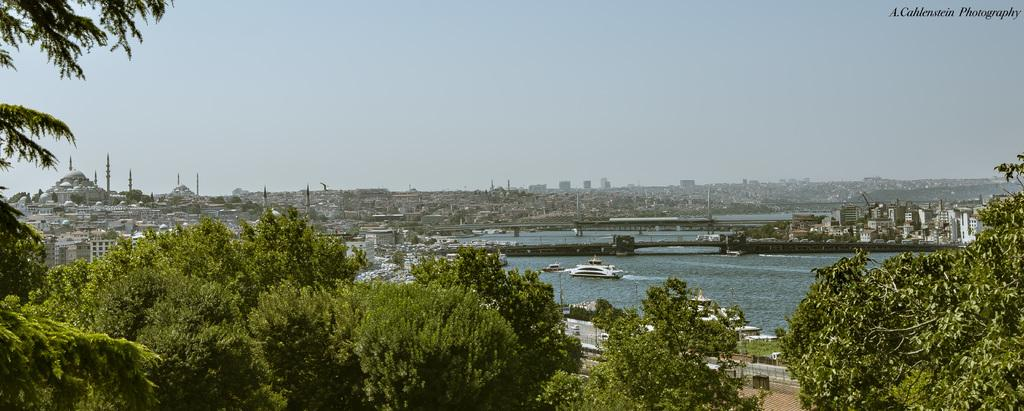What can be seen in the water body in the image? There are boats in a water body in the image. What architectural feature is present in the image? There is a bridge in the image. What type of structures are visible in the image? There is a group of buildings in the image. What tall structures can be seen in the image? There are towers in the image. What type of vegetation is present in the image? There is a group of trees in the image. What are the poles used for in the image? The purpose of the poles in the image is not specified, but they could be used for various purposes such as lighting or signage. How would you describe the sky in the image? The sky is visible in the image and appears cloudy. What class is being taught in the image? There is no class or teaching activity depicted in the image. Is the river flowing in the image? There is no river mentioned in the image; it features a water body with boats. 